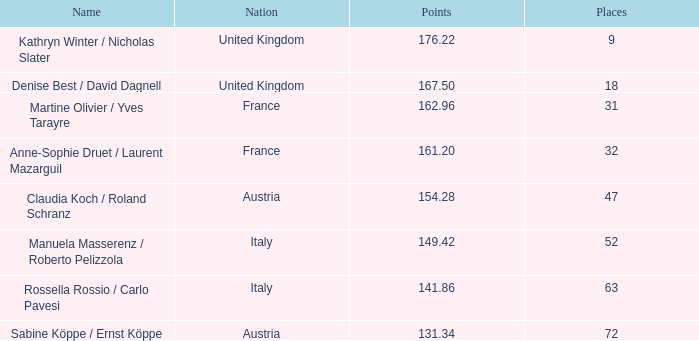Help me parse the entirety of this table. {'header': ['Name', 'Nation', 'Points', 'Places'], 'rows': [['Kathryn Winter / Nicholas Slater', 'United Kingdom', '176.22', '9'], ['Denise Best / David Dagnell', 'United Kingdom', '167.50', '18'], ['Martine Olivier / Yves Tarayre', 'France', '162.96', '31'], ['Anne-Sophie Druet / Laurent Mazarguil', 'France', '161.20', '32'], ['Claudia Koch / Roland Schranz', 'Austria', '154.28', '47'], ['Manuela Masserenz / Roberto Pelizzola', 'Italy', '149.42', '52'], ['Rossella Rossio / Carlo Pavesi', 'Italy', '141.86', '63'], ['Sabine Köppe / Ernst Köppe', 'Austria', '131.34', '72']]} Who has points larger than 167.5? Kathryn Winter / Nicholas Slater. 